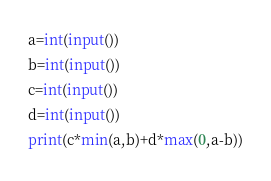Convert code to text. <code><loc_0><loc_0><loc_500><loc_500><_Python_>a=int(input())
b=int(input())
c=int(input())
d=int(input())
print(c*min(a,b)+d*max(0,a-b))</code> 